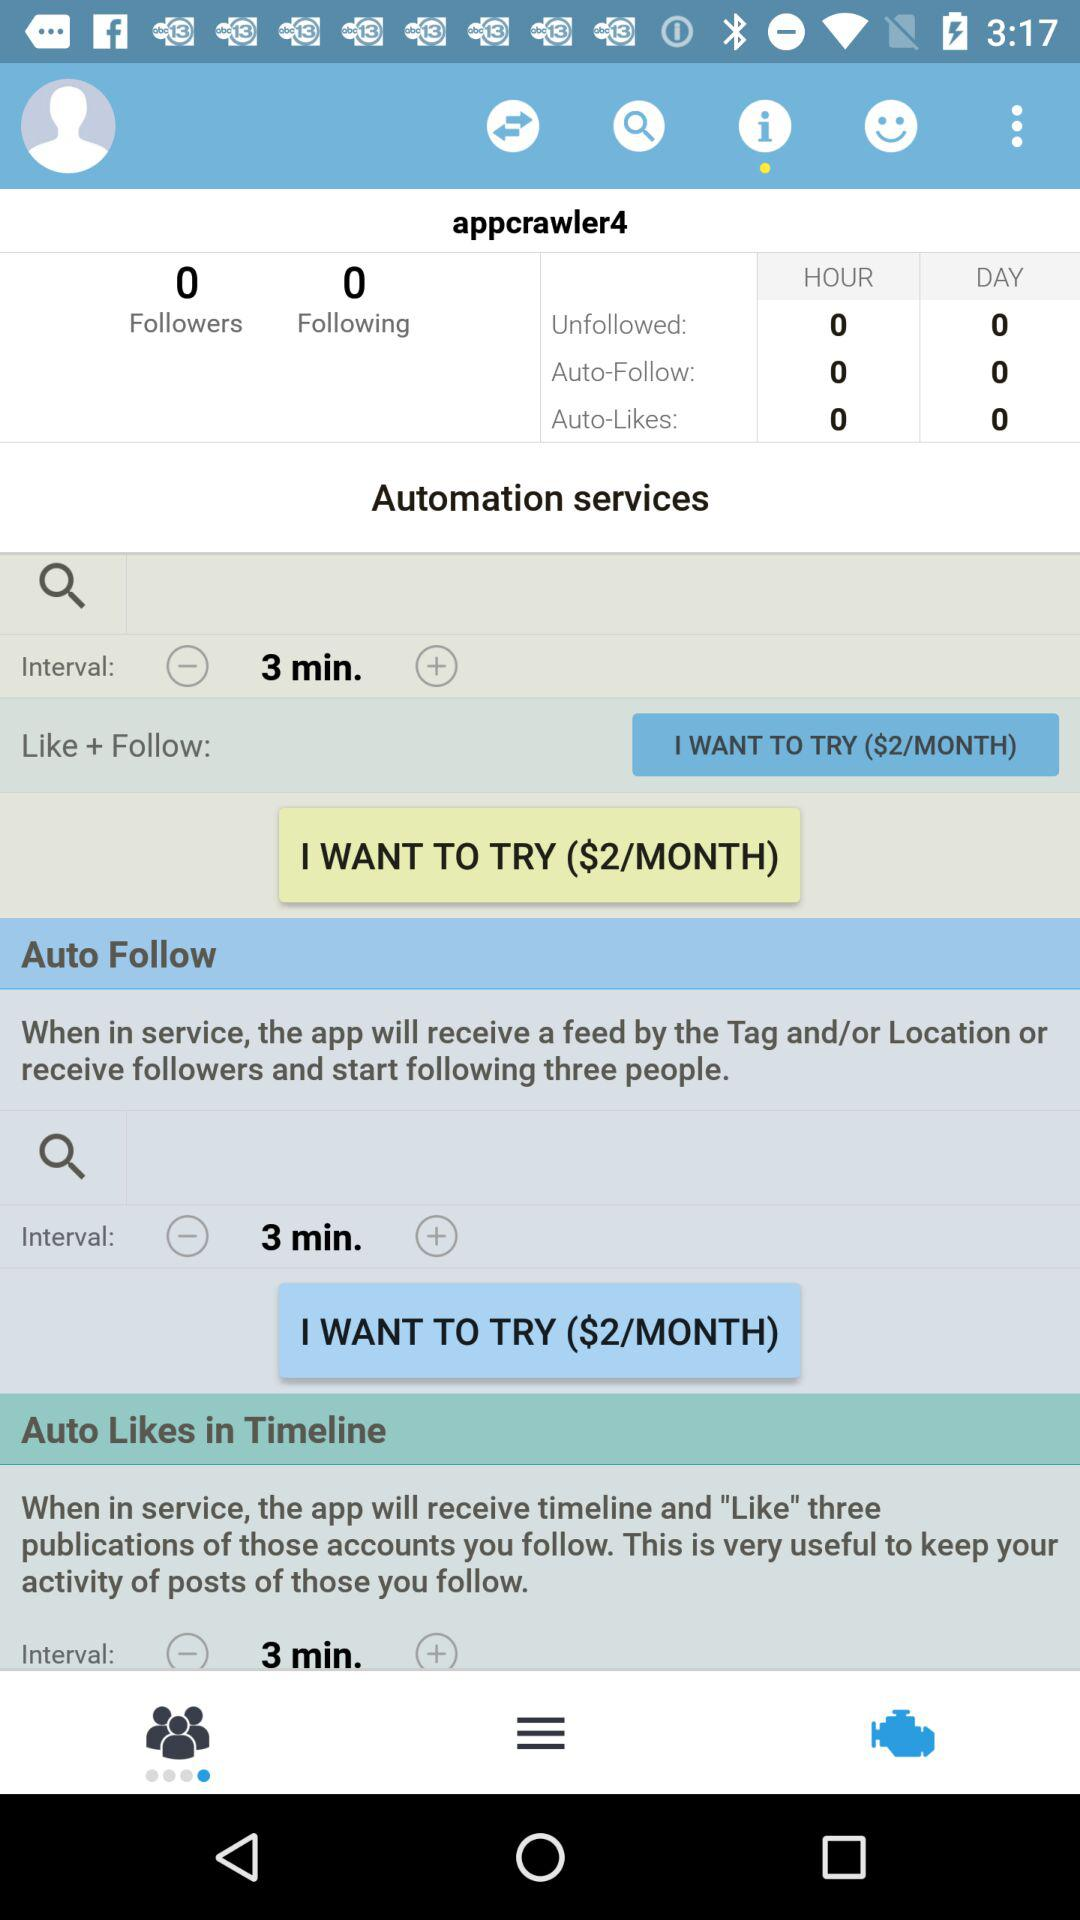How many followers are there? There are 0 followers. 